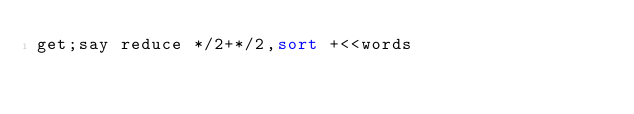Convert code to text. <code><loc_0><loc_0><loc_500><loc_500><_Perl_>get;say reduce */2+*/2,sort +<<words</code> 